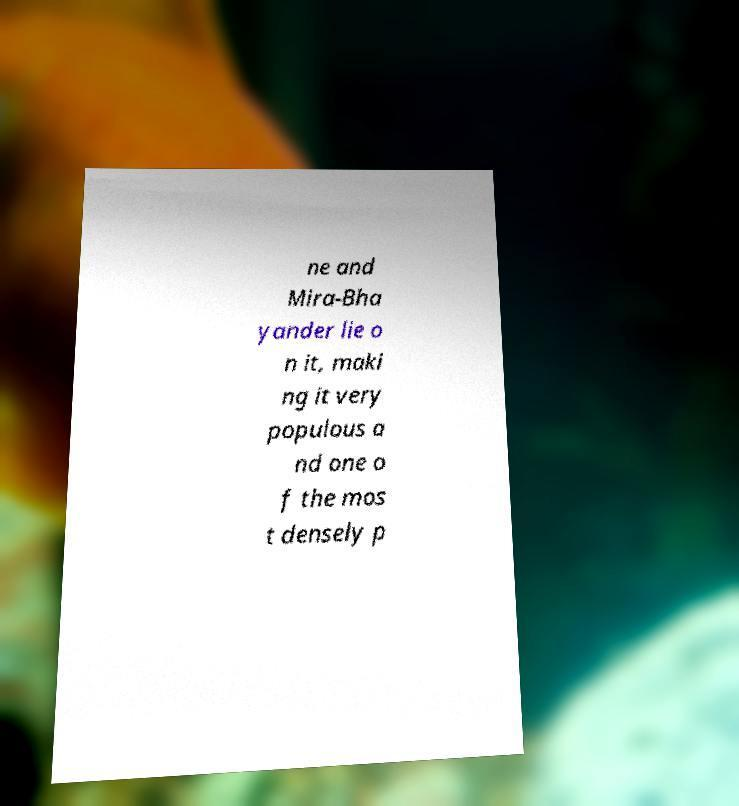Can you accurately transcribe the text from the provided image for me? ne and Mira-Bha yander lie o n it, maki ng it very populous a nd one o f the mos t densely p 